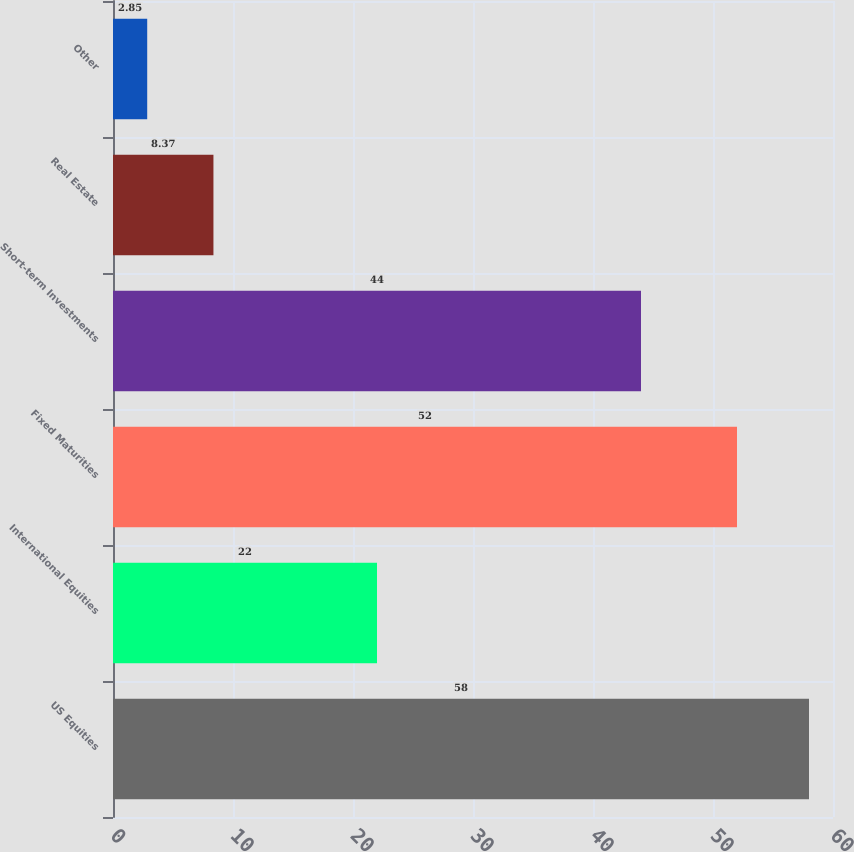<chart> <loc_0><loc_0><loc_500><loc_500><bar_chart><fcel>US Equities<fcel>International Equities<fcel>Fixed Maturities<fcel>Short-term Investments<fcel>Real Estate<fcel>Other<nl><fcel>58<fcel>22<fcel>52<fcel>44<fcel>8.37<fcel>2.85<nl></chart> 